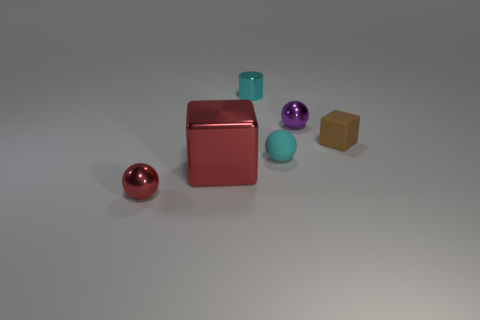Add 4 cyan shiny cylinders. How many objects exist? 10 Subtract all shiny balls. How many balls are left? 1 Subtract all brown blocks. How many blocks are left? 1 Subtract all cylinders. How many objects are left? 5 Subtract 1 spheres. How many spheres are left? 2 Subtract all blue cylinders. Subtract all green spheres. How many cylinders are left? 1 Subtract all brown cylinders. How many brown spheres are left? 0 Subtract all small blue shiny cylinders. Subtract all small cyan shiny things. How many objects are left? 5 Add 6 blocks. How many blocks are left? 8 Add 2 big green objects. How many big green objects exist? 2 